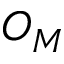<formula> <loc_0><loc_0><loc_500><loc_500>O _ { M }</formula> 